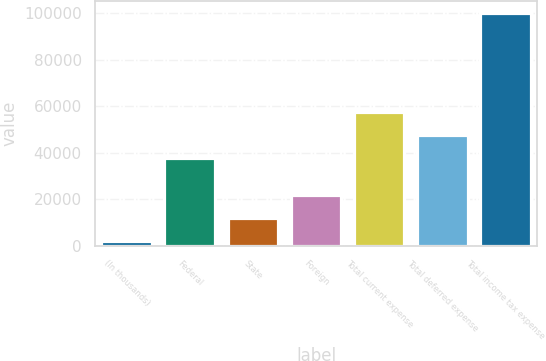Convert chart. <chart><loc_0><loc_0><loc_500><loc_500><bar_chart><fcel>(In thousands)<fcel>Federal<fcel>State<fcel>Foreign<fcel>Total current expense<fcel>Total deferred expense<fcel>Total income tax expense<nl><fcel>2017<fcel>37708<fcel>11830.4<fcel>21643.8<fcel>57334.8<fcel>47521.4<fcel>100151<nl></chart> 